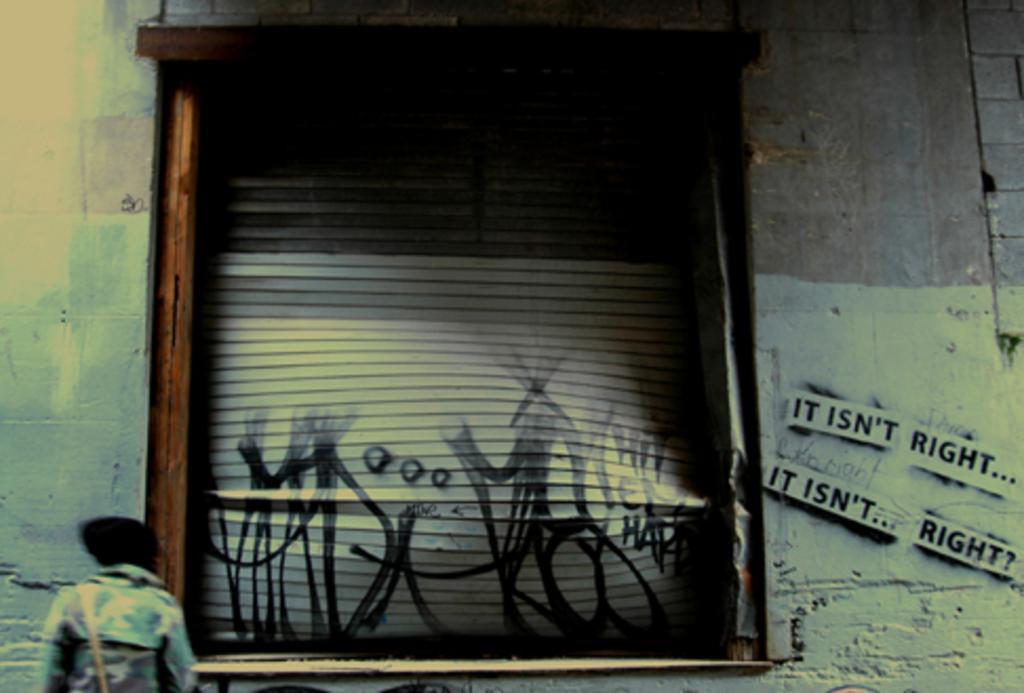Can you describe this image briefly? In this image there is a man standing in front of the wall, in the middle of the wall there is a window, on the of the wall it is written as, it isn't right it, it isn't right. 